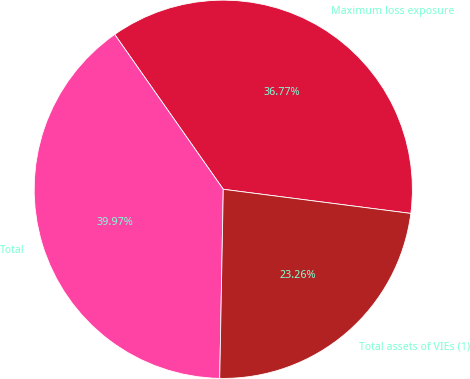<chart> <loc_0><loc_0><loc_500><loc_500><pie_chart><fcel>Maximum loss exposure<fcel>Total<fcel>Total assets of VIEs (1)<nl><fcel>36.77%<fcel>39.97%<fcel>23.26%<nl></chart> 